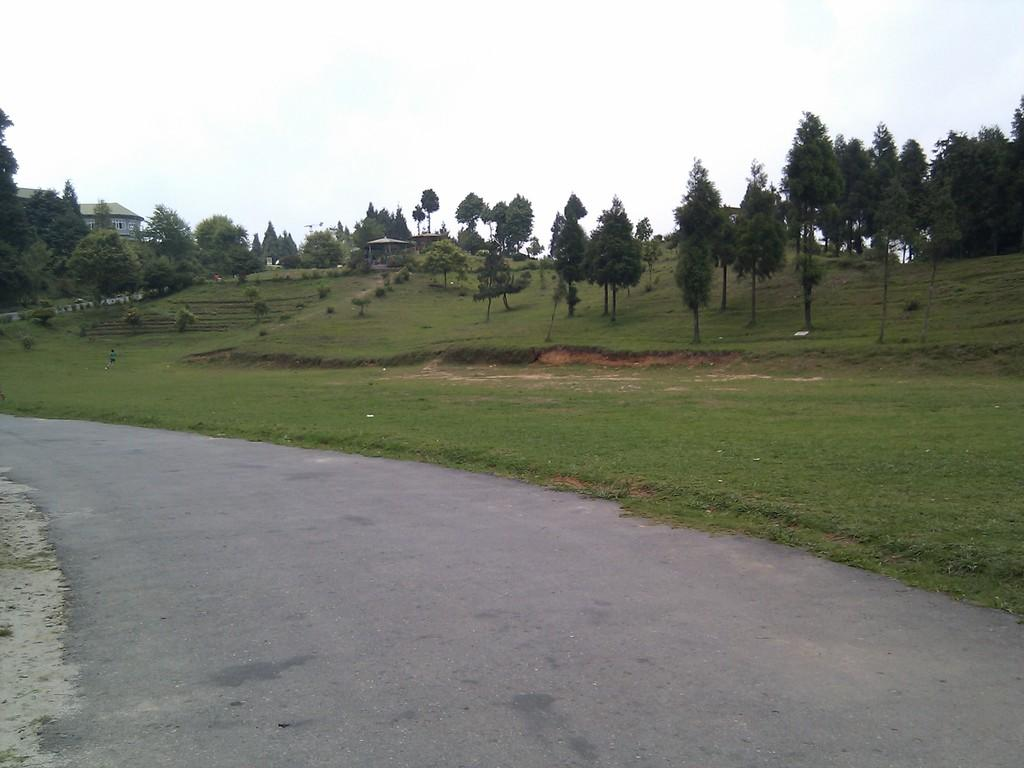What type of vegetation is present in the image? There are trees in the image. What type of ground cover is present in the image? There is grass in the image. What part of the natural environment is visible in the image? The sky is visible in the image. What type of man-made structure is present in the image? There is a road at the bottom of the image. What month is it in the image? The month cannot be determined from the image, as it does not contain any information about the time of year. What is the limit of the trees in the image? There is no limit mentioned for the trees in the image, as the facts provided do not specify any boundaries or restrictions. 